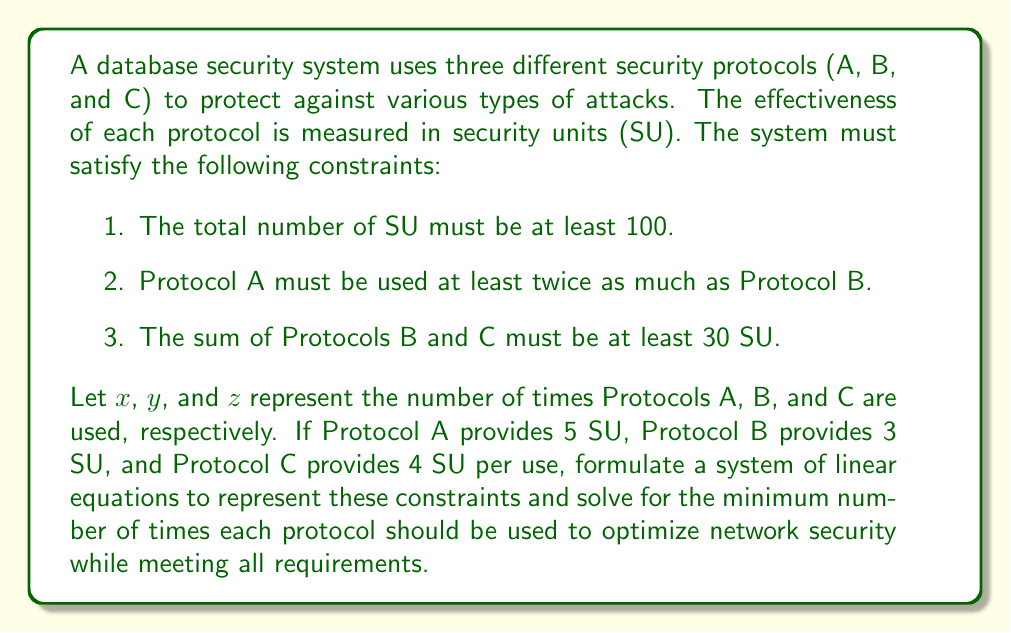Solve this math problem. Let's approach this step-by-step:

1. First, let's define our variables:
   $x$ = number of times Protocol A is used
   $y$ = number of times Protocol B is used
   $z$ = number of times Protocol C is used

2. Now, let's formulate the linear equations based on the given constraints:

   a. Total SU must be at least 100:
      $5x + 3y + 4z \geq 100$

   b. Protocol A must be used at least twice as much as Protocol B:
      $x \geq 2y$

   c. The sum of Protocols B and C must be at least 30 SU:
      $3y + 4z \geq 30$

3. We want to minimize the total number of times the protocols are used, so our objective function is:
   Minimize $x + y + z$

4. To solve this system, we can use the simplex method or other linear programming techniques. However, we can also reason through it:

   - From constraint (b), we know that $x$ should be as close to $2y$ as possible to minimize usage.
   - From constraint (c), we need to satisfy $3y + 4z \geq 30$.
   - The most efficient way to satisfy (c) is to use Protocol C as much as possible, as it provides more SU per use.

5. Let's try to satisfy (c) with minimal usage:
   If $z = 7$, then $4z = 28$
   We need $3y \geq 2$ to satisfy the inequality
   The minimum integer value for $y$ that satisfies this is $y = 1$

6. Now, we know $y = 1$, so $x = 2y = 2$

7. Let's check if this satisfies constraint (a):
   $5(2) + 3(1) + 4(7) = 10 + 3 + 28 = 41$
   This doesn't meet the 100 SU requirement.

8. We need to increase our values. Let's try doubling everything:
   $x = 4$, $y = 2$, $z = 14$

9. Check constraint (a) again:
   $5(4) + 3(2) + 4(14) = 20 + 6 + 56 = 82$
   Still not enough.

10. Let's increase $x$ and $z$ (since they provide more SU per use):
    $x = 6$, $y = 2$, $z = 16$

11. Final check:
    $5(6) + 3(2) + 4(16) = 30 + 6 + 64 = 100$
    This satisfies all constraints and minimizes the total usage.

Therefore, the optimal solution is to use Protocol A 6 times, Protocol B 2 times, and Protocol C 16 times.
Answer: A: 6, B: 2, C: 16 